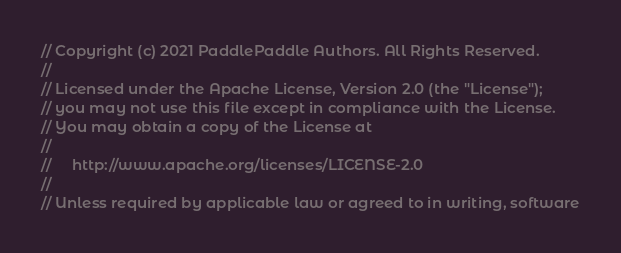Convert code to text. <code><loc_0><loc_0><loc_500><loc_500><_C++_>// Copyright (c) 2021 PaddlePaddle Authors. All Rights Reserved.
//
// Licensed under the Apache License, Version 2.0 (the "License");
// you may not use this file except in compliance with the License.
// You may obtain a copy of the License at
//
//     http://www.apache.org/licenses/LICENSE-2.0
//
// Unless required by applicable law or agreed to in writing, software</code> 